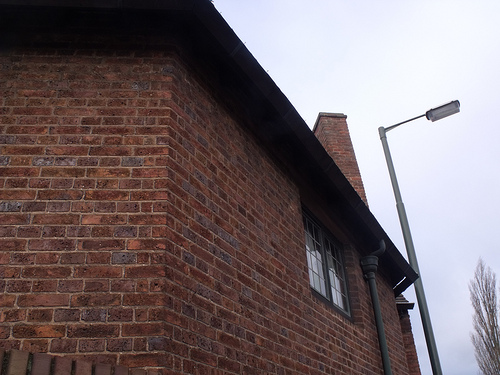<image>
Is there a lamp behind the cloud? No. The lamp is not behind the cloud. From this viewpoint, the lamp appears to be positioned elsewhere in the scene. 